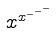Convert formula to latex. <formula><loc_0><loc_0><loc_500><loc_500>x ^ { x ^ { - ^ { - ^ { - } } } }</formula> 